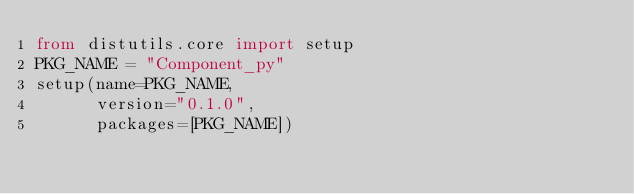Convert code to text. <code><loc_0><loc_0><loc_500><loc_500><_Python_>from distutils.core import setup
PKG_NAME = "Component_py"
setup(name=PKG_NAME,
      version="0.1.0",
      packages=[PKG_NAME])
</code> 